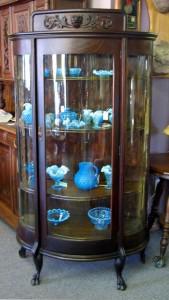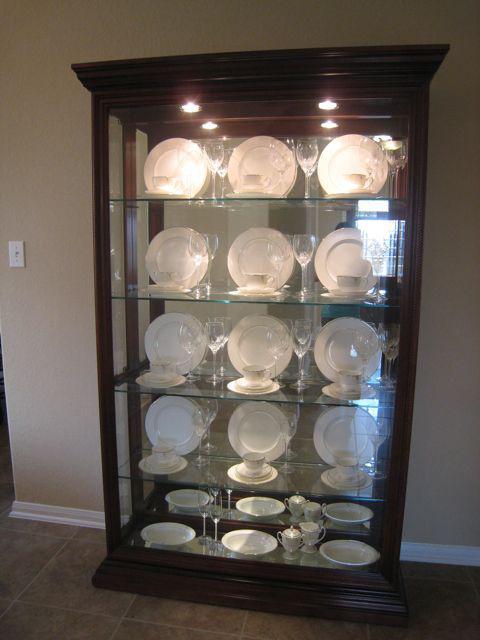The first image is the image on the left, the second image is the image on the right. Evaluate the accuracy of this statement regarding the images: "One image shows a filled cabinet with at least one open paned glass door.". Is it true? Answer yes or no. No. The first image is the image on the left, the second image is the image on the right. Examine the images to the left and right. Is the description "At least two lights are seen at the top of the interior of a china cabinet." accurate? Answer yes or no. Yes. 